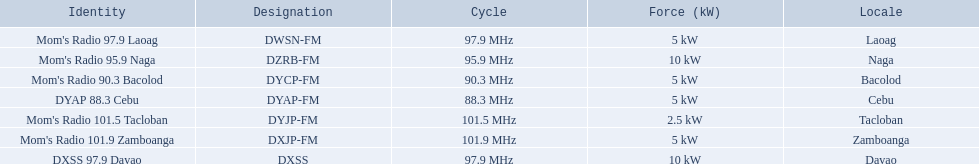What is the power capacity in kw for each team? 5 kW, 10 kW, 5 kW, 5 kW, 2.5 kW, 5 kW, 10 kW. Which is the lowest? 2.5 kW. What station has this amount of power? Mom's Radio 101.5 Tacloban. 